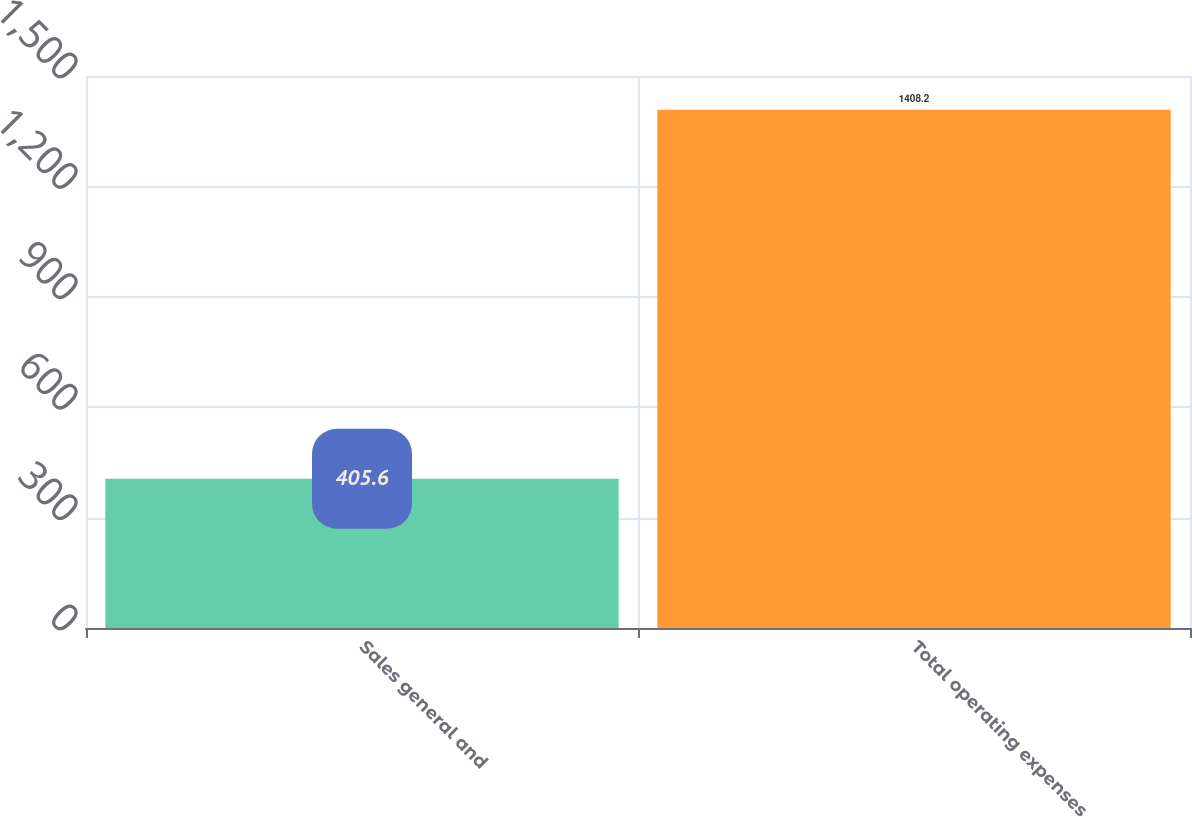<chart> <loc_0><loc_0><loc_500><loc_500><bar_chart><fcel>Sales general and<fcel>Total operating expenses<nl><fcel>405.6<fcel>1408.2<nl></chart> 